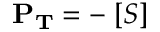Convert formula to latex. <formula><loc_0><loc_0><loc_500><loc_500>P _ { T } = - \partial [ S ]</formula> 